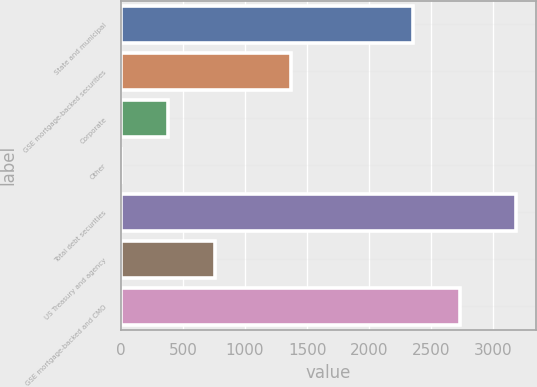<chart> <loc_0><loc_0><loc_500><loc_500><bar_chart><fcel>State and municipal<fcel>GSE mortgage-backed securities<fcel>Corporate<fcel>Other<fcel>Total debt securities<fcel>US Treasury and agency<fcel>GSE mortgage-backed and CMO<nl><fcel>2352.4<fcel>1367.5<fcel>380.58<fcel>1.5<fcel>3185.6<fcel>759.66<fcel>2731.48<nl></chart> 